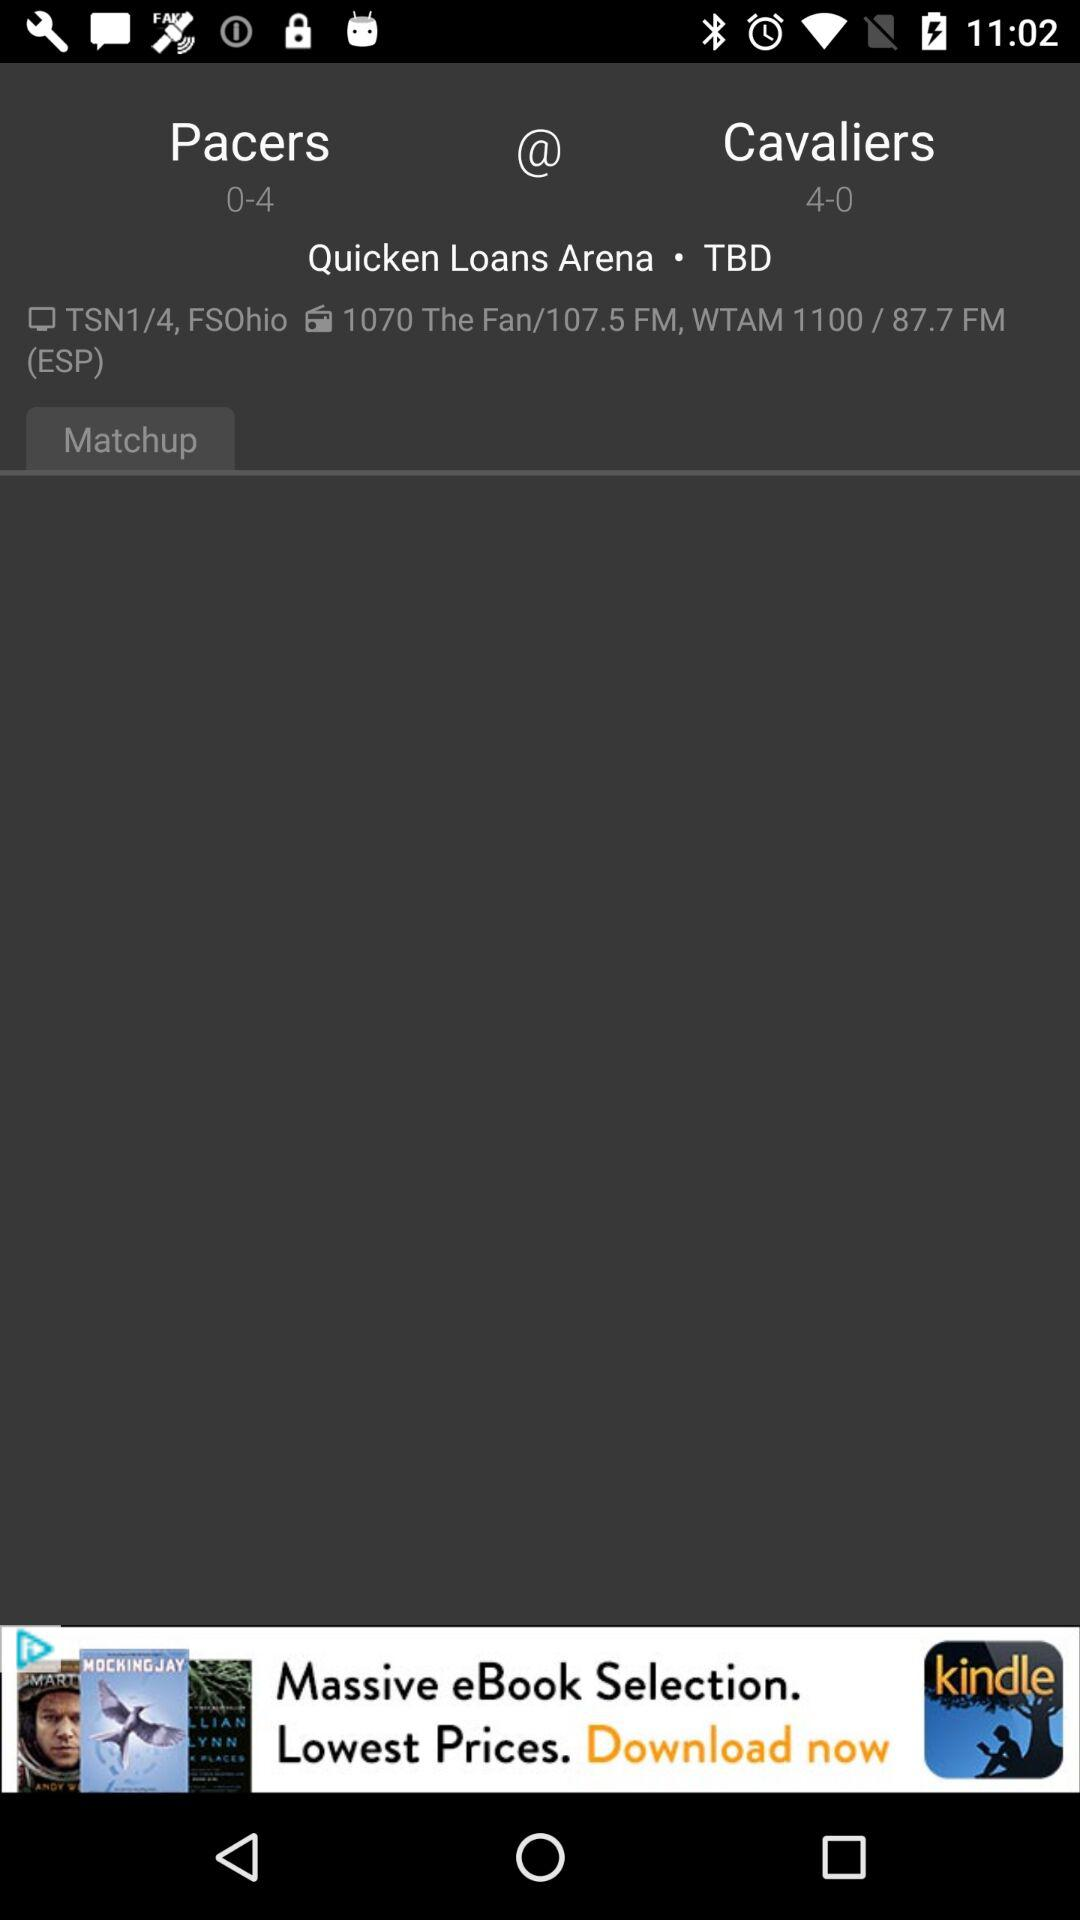How many more games have the Cavaliers won than the Pacers?
Answer the question using a single word or phrase. 4 